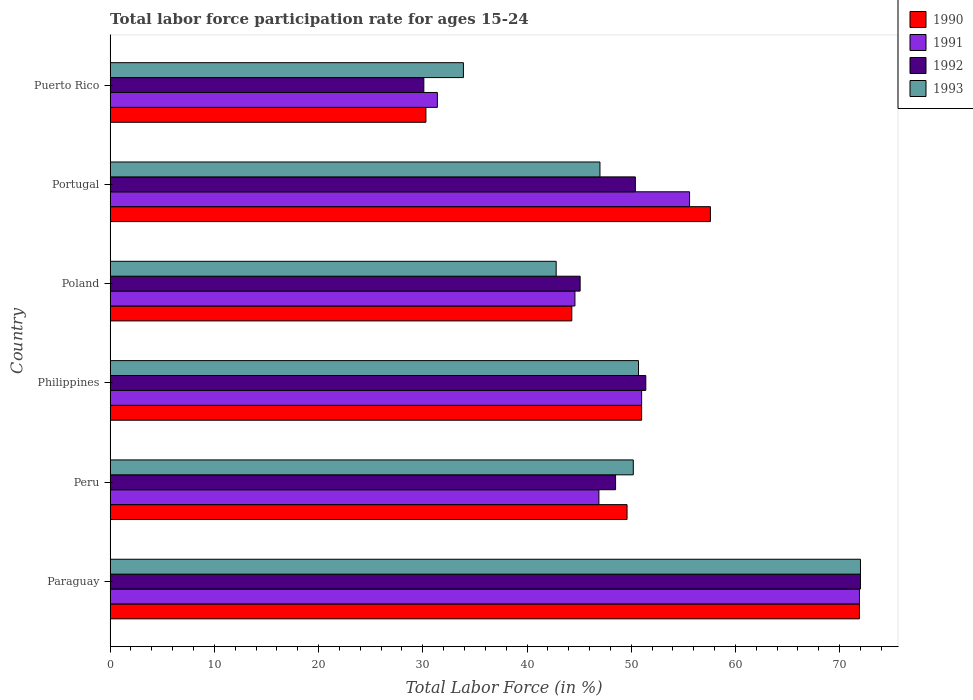How many different coloured bars are there?
Make the answer very short. 4. How many groups of bars are there?
Provide a short and direct response. 6. What is the label of the 5th group of bars from the top?
Your answer should be compact. Peru. What is the labor force participation rate in 1993 in Philippines?
Give a very brief answer. 50.7. Across all countries, what is the maximum labor force participation rate in 1991?
Keep it short and to the point. 71.9. Across all countries, what is the minimum labor force participation rate in 1992?
Ensure brevity in your answer.  30.1. In which country was the labor force participation rate in 1991 maximum?
Offer a very short reply. Paraguay. In which country was the labor force participation rate in 1992 minimum?
Keep it short and to the point. Puerto Rico. What is the total labor force participation rate in 1990 in the graph?
Your response must be concise. 304.7. What is the difference between the labor force participation rate in 1991 in Philippines and that in Portugal?
Your response must be concise. -4.6. What is the difference between the labor force participation rate in 1991 in Portugal and the labor force participation rate in 1993 in Paraguay?
Offer a terse response. -16.4. What is the average labor force participation rate in 1990 per country?
Your answer should be very brief. 50.78. What is the difference between the labor force participation rate in 1991 and labor force participation rate in 1990 in Philippines?
Make the answer very short. 0. In how many countries, is the labor force participation rate in 1991 greater than 48 %?
Offer a very short reply. 3. What is the ratio of the labor force participation rate in 1992 in Philippines to that in Puerto Rico?
Provide a succinct answer. 1.71. Is the labor force participation rate in 1991 in Peru less than that in Portugal?
Your response must be concise. Yes. What is the difference between the highest and the second highest labor force participation rate in 1993?
Ensure brevity in your answer.  21.3. What is the difference between the highest and the lowest labor force participation rate in 1991?
Ensure brevity in your answer.  40.5. What does the 1st bar from the bottom in Peru represents?
Provide a short and direct response. 1990. What is the difference between two consecutive major ticks on the X-axis?
Keep it short and to the point. 10. Does the graph contain any zero values?
Give a very brief answer. No. Does the graph contain grids?
Give a very brief answer. No. Where does the legend appear in the graph?
Provide a succinct answer. Top right. How many legend labels are there?
Offer a very short reply. 4. What is the title of the graph?
Keep it short and to the point. Total labor force participation rate for ages 15-24. Does "1992" appear as one of the legend labels in the graph?
Keep it short and to the point. Yes. What is the label or title of the X-axis?
Your response must be concise. Total Labor Force (in %). What is the label or title of the Y-axis?
Make the answer very short. Country. What is the Total Labor Force (in %) of 1990 in Paraguay?
Provide a short and direct response. 71.9. What is the Total Labor Force (in %) in 1991 in Paraguay?
Provide a short and direct response. 71.9. What is the Total Labor Force (in %) in 1992 in Paraguay?
Your answer should be very brief. 72. What is the Total Labor Force (in %) of 1993 in Paraguay?
Keep it short and to the point. 72. What is the Total Labor Force (in %) in 1990 in Peru?
Provide a short and direct response. 49.6. What is the Total Labor Force (in %) of 1991 in Peru?
Your answer should be compact. 46.9. What is the Total Labor Force (in %) in 1992 in Peru?
Provide a succinct answer. 48.5. What is the Total Labor Force (in %) in 1993 in Peru?
Keep it short and to the point. 50.2. What is the Total Labor Force (in %) in 1990 in Philippines?
Your answer should be very brief. 51. What is the Total Labor Force (in %) of 1991 in Philippines?
Provide a succinct answer. 51. What is the Total Labor Force (in %) of 1992 in Philippines?
Your response must be concise. 51.4. What is the Total Labor Force (in %) of 1993 in Philippines?
Give a very brief answer. 50.7. What is the Total Labor Force (in %) of 1990 in Poland?
Offer a very short reply. 44.3. What is the Total Labor Force (in %) in 1991 in Poland?
Provide a succinct answer. 44.6. What is the Total Labor Force (in %) in 1992 in Poland?
Provide a short and direct response. 45.1. What is the Total Labor Force (in %) in 1993 in Poland?
Your response must be concise. 42.8. What is the Total Labor Force (in %) in 1990 in Portugal?
Your response must be concise. 57.6. What is the Total Labor Force (in %) of 1991 in Portugal?
Your response must be concise. 55.6. What is the Total Labor Force (in %) of 1992 in Portugal?
Ensure brevity in your answer.  50.4. What is the Total Labor Force (in %) in 1993 in Portugal?
Keep it short and to the point. 47. What is the Total Labor Force (in %) of 1990 in Puerto Rico?
Your response must be concise. 30.3. What is the Total Labor Force (in %) of 1991 in Puerto Rico?
Ensure brevity in your answer.  31.4. What is the Total Labor Force (in %) of 1992 in Puerto Rico?
Your response must be concise. 30.1. What is the Total Labor Force (in %) of 1993 in Puerto Rico?
Provide a short and direct response. 33.9. Across all countries, what is the maximum Total Labor Force (in %) in 1990?
Make the answer very short. 71.9. Across all countries, what is the maximum Total Labor Force (in %) in 1991?
Offer a very short reply. 71.9. Across all countries, what is the maximum Total Labor Force (in %) in 1992?
Provide a succinct answer. 72. Across all countries, what is the minimum Total Labor Force (in %) of 1990?
Your answer should be very brief. 30.3. Across all countries, what is the minimum Total Labor Force (in %) in 1991?
Offer a very short reply. 31.4. Across all countries, what is the minimum Total Labor Force (in %) in 1992?
Keep it short and to the point. 30.1. Across all countries, what is the minimum Total Labor Force (in %) in 1993?
Your answer should be compact. 33.9. What is the total Total Labor Force (in %) of 1990 in the graph?
Provide a succinct answer. 304.7. What is the total Total Labor Force (in %) of 1991 in the graph?
Give a very brief answer. 301.4. What is the total Total Labor Force (in %) in 1992 in the graph?
Your response must be concise. 297.5. What is the total Total Labor Force (in %) in 1993 in the graph?
Give a very brief answer. 296.6. What is the difference between the Total Labor Force (in %) of 1990 in Paraguay and that in Peru?
Your answer should be very brief. 22.3. What is the difference between the Total Labor Force (in %) of 1991 in Paraguay and that in Peru?
Give a very brief answer. 25. What is the difference between the Total Labor Force (in %) of 1992 in Paraguay and that in Peru?
Make the answer very short. 23.5. What is the difference between the Total Labor Force (in %) of 1993 in Paraguay and that in Peru?
Your response must be concise. 21.8. What is the difference between the Total Labor Force (in %) of 1990 in Paraguay and that in Philippines?
Give a very brief answer. 20.9. What is the difference between the Total Labor Force (in %) of 1991 in Paraguay and that in Philippines?
Provide a short and direct response. 20.9. What is the difference between the Total Labor Force (in %) of 1992 in Paraguay and that in Philippines?
Give a very brief answer. 20.6. What is the difference between the Total Labor Force (in %) of 1993 in Paraguay and that in Philippines?
Make the answer very short. 21.3. What is the difference between the Total Labor Force (in %) of 1990 in Paraguay and that in Poland?
Your answer should be very brief. 27.6. What is the difference between the Total Labor Force (in %) in 1991 in Paraguay and that in Poland?
Provide a short and direct response. 27.3. What is the difference between the Total Labor Force (in %) in 1992 in Paraguay and that in Poland?
Offer a terse response. 26.9. What is the difference between the Total Labor Force (in %) of 1993 in Paraguay and that in Poland?
Make the answer very short. 29.2. What is the difference between the Total Labor Force (in %) of 1991 in Paraguay and that in Portugal?
Make the answer very short. 16.3. What is the difference between the Total Labor Force (in %) in 1992 in Paraguay and that in Portugal?
Give a very brief answer. 21.6. What is the difference between the Total Labor Force (in %) in 1993 in Paraguay and that in Portugal?
Provide a succinct answer. 25. What is the difference between the Total Labor Force (in %) in 1990 in Paraguay and that in Puerto Rico?
Keep it short and to the point. 41.6. What is the difference between the Total Labor Force (in %) of 1991 in Paraguay and that in Puerto Rico?
Provide a succinct answer. 40.5. What is the difference between the Total Labor Force (in %) of 1992 in Paraguay and that in Puerto Rico?
Make the answer very short. 41.9. What is the difference between the Total Labor Force (in %) of 1993 in Paraguay and that in Puerto Rico?
Your response must be concise. 38.1. What is the difference between the Total Labor Force (in %) of 1991 in Peru and that in Philippines?
Ensure brevity in your answer.  -4.1. What is the difference between the Total Labor Force (in %) of 1993 in Peru and that in Philippines?
Provide a short and direct response. -0.5. What is the difference between the Total Labor Force (in %) in 1990 in Peru and that in Poland?
Your answer should be very brief. 5.3. What is the difference between the Total Labor Force (in %) of 1992 in Peru and that in Poland?
Your answer should be compact. 3.4. What is the difference between the Total Labor Force (in %) of 1990 in Peru and that in Portugal?
Make the answer very short. -8. What is the difference between the Total Labor Force (in %) of 1991 in Peru and that in Portugal?
Offer a terse response. -8.7. What is the difference between the Total Labor Force (in %) of 1990 in Peru and that in Puerto Rico?
Make the answer very short. 19.3. What is the difference between the Total Labor Force (in %) in 1992 in Peru and that in Puerto Rico?
Provide a short and direct response. 18.4. What is the difference between the Total Labor Force (in %) of 1993 in Peru and that in Puerto Rico?
Give a very brief answer. 16.3. What is the difference between the Total Labor Force (in %) in 1993 in Philippines and that in Poland?
Your response must be concise. 7.9. What is the difference between the Total Labor Force (in %) of 1990 in Philippines and that in Portugal?
Keep it short and to the point. -6.6. What is the difference between the Total Labor Force (in %) of 1991 in Philippines and that in Portugal?
Your response must be concise. -4.6. What is the difference between the Total Labor Force (in %) of 1992 in Philippines and that in Portugal?
Offer a very short reply. 1. What is the difference between the Total Labor Force (in %) in 1990 in Philippines and that in Puerto Rico?
Provide a short and direct response. 20.7. What is the difference between the Total Labor Force (in %) in 1991 in Philippines and that in Puerto Rico?
Provide a succinct answer. 19.6. What is the difference between the Total Labor Force (in %) of 1992 in Philippines and that in Puerto Rico?
Keep it short and to the point. 21.3. What is the difference between the Total Labor Force (in %) in 1990 in Poland and that in Portugal?
Provide a succinct answer. -13.3. What is the difference between the Total Labor Force (in %) in 1991 in Poland and that in Puerto Rico?
Keep it short and to the point. 13.2. What is the difference between the Total Labor Force (in %) of 1990 in Portugal and that in Puerto Rico?
Give a very brief answer. 27.3. What is the difference between the Total Labor Force (in %) in 1991 in Portugal and that in Puerto Rico?
Make the answer very short. 24.2. What is the difference between the Total Labor Force (in %) in 1992 in Portugal and that in Puerto Rico?
Your response must be concise. 20.3. What is the difference between the Total Labor Force (in %) in 1990 in Paraguay and the Total Labor Force (in %) in 1991 in Peru?
Offer a very short reply. 25. What is the difference between the Total Labor Force (in %) in 1990 in Paraguay and the Total Labor Force (in %) in 1992 in Peru?
Your answer should be compact. 23.4. What is the difference between the Total Labor Force (in %) of 1990 in Paraguay and the Total Labor Force (in %) of 1993 in Peru?
Your response must be concise. 21.7. What is the difference between the Total Labor Force (in %) of 1991 in Paraguay and the Total Labor Force (in %) of 1992 in Peru?
Offer a very short reply. 23.4. What is the difference between the Total Labor Force (in %) of 1991 in Paraguay and the Total Labor Force (in %) of 1993 in Peru?
Offer a very short reply. 21.7. What is the difference between the Total Labor Force (in %) of 1992 in Paraguay and the Total Labor Force (in %) of 1993 in Peru?
Offer a very short reply. 21.8. What is the difference between the Total Labor Force (in %) in 1990 in Paraguay and the Total Labor Force (in %) in 1991 in Philippines?
Keep it short and to the point. 20.9. What is the difference between the Total Labor Force (in %) in 1990 in Paraguay and the Total Labor Force (in %) in 1993 in Philippines?
Make the answer very short. 21.2. What is the difference between the Total Labor Force (in %) in 1991 in Paraguay and the Total Labor Force (in %) in 1993 in Philippines?
Provide a short and direct response. 21.2. What is the difference between the Total Labor Force (in %) of 1992 in Paraguay and the Total Labor Force (in %) of 1993 in Philippines?
Provide a succinct answer. 21.3. What is the difference between the Total Labor Force (in %) of 1990 in Paraguay and the Total Labor Force (in %) of 1991 in Poland?
Provide a succinct answer. 27.3. What is the difference between the Total Labor Force (in %) of 1990 in Paraguay and the Total Labor Force (in %) of 1992 in Poland?
Keep it short and to the point. 26.8. What is the difference between the Total Labor Force (in %) of 1990 in Paraguay and the Total Labor Force (in %) of 1993 in Poland?
Give a very brief answer. 29.1. What is the difference between the Total Labor Force (in %) of 1991 in Paraguay and the Total Labor Force (in %) of 1992 in Poland?
Provide a succinct answer. 26.8. What is the difference between the Total Labor Force (in %) in 1991 in Paraguay and the Total Labor Force (in %) in 1993 in Poland?
Give a very brief answer. 29.1. What is the difference between the Total Labor Force (in %) in 1992 in Paraguay and the Total Labor Force (in %) in 1993 in Poland?
Your response must be concise. 29.2. What is the difference between the Total Labor Force (in %) in 1990 in Paraguay and the Total Labor Force (in %) in 1992 in Portugal?
Your answer should be very brief. 21.5. What is the difference between the Total Labor Force (in %) in 1990 in Paraguay and the Total Labor Force (in %) in 1993 in Portugal?
Keep it short and to the point. 24.9. What is the difference between the Total Labor Force (in %) in 1991 in Paraguay and the Total Labor Force (in %) in 1993 in Portugal?
Offer a very short reply. 24.9. What is the difference between the Total Labor Force (in %) in 1992 in Paraguay and the Total Labor Force (in %) in 1993 in Portugal?
Offer a terse response. 25. What is the difference between the Total Labor Force (in %) in 1990 in Paraguay and the Total Labor Force (in %) in 1991 in Puerto Rico?
Give a very brief answer. 40.5. What is the difference between the Total Labor Force (in %) of 1990 in Paraguay and the Total Labor Force (in %) of 1992 in Puerto Rico?
Your answer should be compact. 41.8. What is the difference between the Total Labor Force (in %) in 1991 in Paraguay and the Total Labor Force (in %) in 1992 in Puerto Rico?
Offer a very short reply. 41.8. What is the difference between the Total Labor Force (in %) of 1992 in Paraguay and the Total Labor Force (in %) of 1993 in Puerto Rico?
Offer a very short reply. 38.1. What is the difference between the Total Labor Force (in %) in 1990 in Peru and the Total Labor Force (in %) in 1991 in Philippines?
Your answer should be very brief. -1.4. What is the difference between the Total Labor Force (in %) in 1992 in Peru and the Total Labor Force (in %) in 1993 in Philippines?
Your response must be concise. -2.2. What is the difference between the Total Labor Force (in %) in 1990 in Peru and the Total Labor Force (in %) in 1992 in Poland?
Keep it short and to the point. 4.5. What is the difference between the Total Labor Force (in %) of 1991 in Peru and the Total Labor Force (in %) of 1992 in Poland?
Give a very brief answer. 1.8. What is the difference between the Total Labor Force (in %) of 1992 in Peru and the Total Labor Force (in %) of 1993 in Poland?
Give a very brief answer. 5.7. What is the difference between the Total Labor Force (in %) of 1990 in Peru and the Total Labor Force (in %) of 1991 in Portugal?
Make the answer very short. -6. What is the difference between the Total Labor Force (in %) of 1991 in Peru and the Total Labor Force (in %) of 1993 in Portugal?
Make the answer very short. -0.1. What is the difference between the Total Labor Force (in %) in 1992 in Peru and the Total Labor Force (in %) in 1993 in Portugal?
Provide a short and direct response. 1.5. What is the difference between the Total Labor Force (in %) of 1990 in Peru and the Total Labor Force (in %) of 1991 in Puerto Rico?
Offer a terse response. 18.2. What is the difference between the Total Labor Force (in %) in 1990 in Peru and the Total Labor Force (in %) in 1992 in Puerto Rico?
Provide a short and direct response. 19.5. What is the difference between the Total Labor Force (in %) of 1990 in Peru and the Total Labor Force (in %) of 1993 in Puerto Rico?
Give a very brief answer. 15.7. What is the difference between the Total Labor Force (in %) in 1991 in Peru and the Total Labor Force (in %) in 1993 in Puerto Rico?
Make the answer very short. 13. What is the difference between the Total Labor Force (in %) in 1990 in Philippines and the Total Labor Force (in %) in 1991 in Poland?
Provide a short and direct response. 6.4. What is the difference between the Total Labor Force (in %) in 1992 in Philippines and the Total Labor Force (in %) in 1993 in Poland?
Ensure brevity in your answer.  8.6. What is the difference between the Total Labor Force (in %) of 1991 in Philippines and the Total Labor Force (in %) of 1993 in Portugal?
Your response must be concise. 4. What is the difference between the Total Labor Force (in %) of 1990 in Philippines and the Total Labor Force (in %) of 1991 in Puerto Rico?
Make the answer very short. 19.6. What is the difference between the Total Labor Force (in %) of 1990 in Philippines and the Total Labor Force (in %) of 1992 in Puerto Rico?
Provide a short and direct response. 20.9. What is the difference between the Total Labor Force (in %) of 1990 in Philippines and the Total Labor Force (in %) of 1993 in Puerto Rico?
Offer a terse response. 17.1. What is the difference between the Total Labor Force (in %) in 1991 in Philippines and the Total Labor Force (in %) in 1992 in Puerto Rico?
Your answer should be very brief. 20.9. What is the difference between the Total Labor Force (in %) of 1990 in Poland and the Total Labor Force (in %) of 1991 in Portugal?
Give a very brief answer. -11.3. What is the difference between the Total Labor Force (in %) of 1990 in Poland and the Total Labor Force (in %) of 1993 in Portugal?
Provide a succinct answer. -2.7. What is the difference between the Total Labor Force (in %) of 1991 in Poland and the Total Labor Force (in %) of 1993 in Portugal?
Offer a very short reply. -2.4. What is the difference between the Total Labor Force (in %) in 1992 in Poland and the Total Labor Force (in %) in 1993 in Portugal?
Offer a very short reply. -1.9. What is the difference between the Total Labor Force (in %) in 1990 in Poland and the Total Labor Force (in %) in 1992 in Puerto Rico?
Ensure brevity in your answer.  14.2. What is the difference between the Total Labor Force (in %) of 1990 in Poland and the Total Labor Force (in %) of 1993 in Puerto Rico?
Your answer should be compact. 10.4. What is the difference between the Total Labor Force (in %) in 1991 in Poland and the Total Labor Force (in %) in 1992 in Puerto Rico?
Provide a short and direct response. 14.5. What is the difference between the Total Labor Force (in %) in 1992 in Poland and the Total Labor Force (in %) in 1993 in Puerto Rico?
Provide a short and direct response. 11.2. What is the difference between the Total Labor Force (in %) of 1990 in Portugal and the Total Labor Force (in %) of 1991 in Puerto Rico?
Your response must be concise. 26.2. What is the difference between the Total Labor Force (in %) of 1990 in Portugal and the Total Labor Force (in %) of 1993 in Puerto Rico?
Keep it short and to the point. 23.7. What is the difference between the Total Labor Force (in %) of 1991 in Portugal and the Total Labor Force (in %) of 1992 in Puerto Rico?
Offer a very short reply. 25.5. What is the difference between the Total Labor Force (in %) in 1991 in Portugal and the Total Labor Force (in %) in 1993 in Puerto Rico?
Your response must be concise. 21.7. What is the difference between the Total Labor Force (in %) of 1992 in Portugal and the Total Labor Force (in %) of 1993 in Puerto Rico?
Your answer should be very brief. 16.5. What is the average Total Labor Force (in %) in 1990 per country?
Give a very brief answer. 50.78. What is the average Total Labor Force (in %) of 1991 per country?
Make the answer very short. 50.23. What is the average Total Labor Force (in %) of 1992 per country?
Provide a short and direct response. 49.58. What is the average Total Labor Force (in %) of 1993 per country?
Your response must be concise. 49.43. What is the difference between the Total Labor Force (in %) in 1990 and Total Labor Force (in %) in 1992 in Paraguay?
Provide a short and direct response. -0.1. What is the difference between the Total Labor Force (in %) of 1991 and Total Labor Force (in %) of 1992 in Paraguay?
Provide a short and direct response. -0.1. What is the difference between the Total Labor Force (in %) in 1991 and Total Labor Force (in %) in 1993 in Paraguay?
Your answer should be compact. -0.1. What is the difference between the Total Labor Force (in %) in 1992 and Total Labor Force (in %) in 1993 in Paraguay?
Keep it short and to the point. 0. What is the difference between the Total Labor Force (in %) in 1990 and Total Labor Force (in %) in 1992 in Philippines?
Provide a succinct answer. -0.4. What is the difference between the Total Labor Force (in %) in 1990 and Total Labor Force (in %) in 1993 in Philippines?
Offer a very short reply. 0.3. What is the difference between the Total Labor Force (in %) in 1991 and Total Labor Force (in %) in 1992 in Philippines?
Your answer should be compact. -0.4. What is the difference between the Total Labor Force (in %) of 1991 and Total Labor Force (in %) of 1993 in Philippines?
Provide a succinct answer. 0.3. What is the difference between the Total Labor Force (in %) in 1992 and Total Labor Force (in %) in 1993 in Philippines?
Your response must be concise. 0.7. What is the difference between the Total Labor Force (in %) of 1990 and Total Labor Force (in %) of 1991 in Poland?
Give a very brief answer. -0.3. What is the difference between the Total Labor Force (in %) of 1990 and Total Labor Force (in %) of 1992 in Poland?
Offer a very short reply. -0.8. What is the difference between the Total Labor Force (in %) in 1991 and Total Labor Force (in %) in 1992 in Poland?
Provide a succinct answer. -0.5. What is the difference between the Total Labor Force (in %) of 1991 and Total Labor Force (in %) of 1993 in Poland?
Offer a terse response. 1.8. What is the difference between the Total Labor Force (in %) in 1992 and Total Labor Force (in %) in 1993 in Poland?
Your response must be concise. 2.3. What is the difference between the Total Labor Force (in %) of 1990 and Total Labor Force (in %) of 1992 in Portugal?
Make the answer very short. 7.2. What is the difference between the Total Labor Force (in %) in 1990 and Total Labor Force (in %) in 1993 in Portugal?
Offer a very short reply. 10.6. What is the difference between the Total Labor Force (in %) in 1991 and Total Labor Force (in %) in 1992 in Puerto Rico?
Give a very brief answer. 1.3. What is the difference between the Total Labor Force (in %) of 1992 and Total Labor Force (in %) of 1993 in Puerto Rico?
Provide a short and direct response. -3.8. What is the ratio of the Total Labor Force (in %) in 1990 in Paraguay to that in Peru?
Make the answer very short. 1.45. What is the ratio of the Total Labor Force (in %) of 1991 in Paraguay to that in Peru?
Provide a short and direct response. 1.53. What is the ratio of the Total Labor Force (in %) of 1992 in Paraguay to that in Peru?
Give a very brief answer. 1.48. What is the ratio of the Total Labor Force (in %) in 1993 in Paraguay to that in Peru?
Your answer should be very brief. 1.43. What is the ratio of the Total Labor Force (in %) of 1990 in Paraguay to that in Philippines?
Your response must be concise. 1.41. What is the ratio of the Total Labor Force (in %) of 1991 in Paraguay to that in Philippines?
Give a very brief answer. 1.41. What is the ratio of the Total Labor Force (in %) in 1992 in Paraguay to that in Philippines?
Give a very brief answer. 1.4. What is the ratio of the Total Labor Force (in %) in 1993 in Paraguay to that in Philippines?
Keep it short and to the point. 1.42. What is the ratio of the Total Labor Force (in %) of 1990 in Paraguay to that in Poland?
Your response must be concise. 1.62. What is the ratio of the Total Labor Force (in %) in 1991 in Paraguay to that in Poland?
Provide a succinct answer. 1.61. What is the ratio of the Total Labor Force (in %) in 1992 in Paraguay to that in Poland?
Keep it short and to the point. 1.6. What is the ratio of the Total Labor Force (in %) of 1993 in Paraguay to that in Poland?
Provide a succinct answer. 1.68. What is the ratio of the Total Labor Force (in %) of 1990 in Paraguay to that in Portugal?
Make the answer very short. 1.25. What is the ratio of the Total Labor Force (in %) of 1991 in Paraguay to that in Portugal?
Your answer should be very brief. 1.29. What is the ratio of the Total Labor Force (in %) in 1992 in Paraguay to that in Portugal?
Give a very brief answer. 1.43. What is the ratio of the Total Labor Force (in %) in 1993 in Paraguay to that in Portugal?
Offer a very short reply. 1.53. What is the ratio of the Total Labor Force (in %) in 1990 in Paraguay to that in Puerto Rico?
Your answer should be very brief. 2.37. What is the ratio of the Total Labor Force (in %) of 1991 in Paraguay to that in Puerto Rico?
Offer a very short reply. 2.29. What is the ratio of the Total Labor Force (in %) of 1992 in Paraguay to that in Puerto Rico?
Give a very brief answer. 2.39. What is the ratio of the Total Labor Force (in %) in 1993 in Paraguay to that in Puerto Rico?
Your answer should be compact. 2.12. What is the ratio of the Total Labor Force (in %) in 1990 in Peru to that in Philippines?
Give a very brief answer. 0.97. What is the ratio of the Total Labor Force (in %) in 1991 in Peru to that in Philippines?
Offer a terse response. 0.92. What is the ratio of the Total Labor Force (in %) in 1992 in Peru to that in Philippines?
Keep it short and to the point. 0.94. What is the ratio of the Total Labor Force (in %) of 1993 in Peru to that in Philippines?
Provide a succinct answer. 0.99. What is the ratio of the Total Labor Force (in %) of 1990 in Peru to that in Poland?
Offer a terse response. 1.12. What is the ratio of the Total Labor Force (in %) in 1991 in Peru to that in Poland?
Offer a terse response. 1.05. What is the ratio of the Total Labor Force (in %) of 1992 in Peru to that in Poland?
Provide a succinct answer. 1.08. What is the ratio of the Total Labor Force (in %) of 1993 in Peru to that in Poland?
Offer a terse response. 1.17. What is the ratio of the Total Labor Force (in %) in 1990 in Peru to that in Portugal?
Your answer should be very brief. 0.86. What is the ratio of the Total Labor Force (in %) of 1991 in Peru to that in Portugal?
Keep it short and to the point. 0.84. What is the ratio of the Total Labor Force (in %) of 1992 in Peru to that in Portugal?
Your answer should be compact. 0.96. What is the ratio of the Total Labor Force (in %) in 1993 in Peru to that in Portugal?
Your answer should be compact. 1.07. What is the ratio of the Total Labor Force (in %) in 1990 in Peru to that in Puerto Rico?
Your response must be concise. 1.64. What is the ratio of the Total Labor Force (in %) in 1991 in Peru to that in Puerto Rico?
Make the answer very short. 1.49. What is the ratio of the Total Labor Force (in %) in 1992 in Peru to that in Puerto Rico?
Your response must be concise. 1.61. What is the ratio of the Total Labor Force (in %) in 1993 in Peru to that in Puerto Rico?
Provide a short and direct response. 1.48. What is the ratio of the Total Labor Force (in %) in 1990 in Philippines to that in Poland?
Provide a succinct answer. 1.15. What is the ratio of the Total Labor Force (in %) of 1991 in Philippines to that in Poland?
Make the answer very short. 1.14. What is the ratio of the Total Labor Force (in %) of 1992 in Philippines to that in Poland?
Your answer should be compact. 1.14. What is the ratio of the Total Labor Force (in %) of 1993 in Philippines to that in Poland?
Your answer should be very brief. 1.18. What is the ratio of the Total Labor Force (in %) of 1990 in Philippines to that in Portugal?
Your response must be concise. 0.89. What is the ratio of the Total Labor Force (in %) of 1991 in Philippines to that in Portugal?
Give a very brief answer. 0.92. What is the ratio of the Total Labor Force (in %) of 1992 in Philippines to that in Portugal?
Offer a terse response. 1.02. What is the ratio of the Total Labor Force (in %) in 1993 in Philippines to that in Portugal?
Keep it short and to the point. 1.08. What is the ratio of the Total Labor Force (in %) of 1990 in Philippines to that in Puerto Rico?
Offer a terse response. 1.68. What is the ratio of the Total Labor Force (in %) in 1991 in Philippines to that in Puerto Rico?
Ensure brevity in your answer.  1.62. What is the ratio of the Total Labor Force (in %) of 1992 in Philippines to that in Puerto Rico?
Your answer should be compact. 1.71. What is the ratio of the Total Labor Force (in %) in 1993 in Philippines to that in Puerto Rico?
Keep it short and to the point. 1.5. What is the ratio of the Total Labor Force (in %) in 1990 in Poland to that in Portugal?
Provide a succinct answer. 0.77. What is the ratio of the Total Labor Force (in %) of 1991 in Poland to that in Portugal?
Your response must be concise. 0.8. What is the ratio of the Total Labor Force (in %) in 1992 in Poland to that in Portugal?
Ensure brevity in your answer.  0.89. What is the ratio of the Total Labor Force (in %) of 1993 in Poland to that in Portugal?
Your response must be concise. 0.91. What is the ratio of the Total Labor Force (in %) in 1990 in Poland to that in Puerto Rico?
Offer a terse response. 1.46. What is the ratio of the Total Labor Force (in %) in 1991 in Poland to that in Puerto Rico?
Make the answer very short. 1.42. What is the ratio of the Total Labor Force (in %) in 1992 in Poland to that in Puerto Rico?
Provide a short and direct response. 1.5. What is the ratio of the Total Labor Force (in %) of 1993 in Poland to that in Puerto Rico?
Ensure brevity in your answer.  1.26. What is the ratio of the Total Labor Force (in %) in 1990 in Portugal to that in Puerto Rico?
Ensure brevity in your answer.  1.9. What is the ratio of the Total Labor Force (in %) of 1991 in Portugal to that in Puerto Rico?
Your answer should be compact. 1.77. What is the ratio of the Total Labor Force (in %) in 1992 in Portugal to that in Puerto Rico?
Your answer should be compact. 1.67. What is the ratio of the Total Labor Force (in %) of 1993 in Portugal to that in Puerto Rico?
Your answer should be compact. 1.39. What is the difference between the highest and the second highest Total Labor Force (in %) in 1991?
Provide a succinct answer. 16.3. What is the difference between the highest and the second highest Total Labor Force (in %) of 1992?
Ensure brevity in your answer.  20.6. What is the difference between the highest and the second highest Total Labor Force (in %) in 1993?
Your answer should be very brief. 21.3. What is the difference between the highest and the lowest Total Labor Force (in %) of 1990?
Offer a very short reply. 41.6. What is the difference between the highest and the lowest Total Labor Force (in %) of 1991?
Keep it short and to the point. 40.5. What is the difference between the highest and the lowest Total Labor Force (in %) in 1992?
Keep it short and to the point. 41.9. What is the difference between the highest and the lowest Total Labor Force (in %) in 1993?
Give a very brief answer. 38.1. 